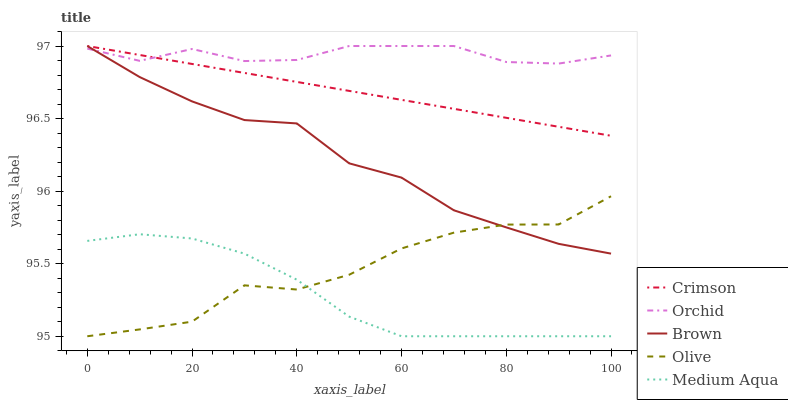Does Medium Aqua have the minimum area under the curve?
Answer yes or no. Yes. Does Orchid have the maximum area under the curve?
Answer yes or no. Yes. Does Brown have the minimum area under the curve?
Answer yes or no. No. Does Brown have the maximum area under the curve?
Answer yes or no. No. Is Crimson the smoothest?
Answer yes or no. Yes. Is Olive the roughest?
Answer yes or no. Yes. Is Brown the smoothest?
Answer yes or no. No. Is Brown the roughest?
Answer yes or no. No. Does Olive have the lowest value?
Answer yes or no. Yes. Does Brown have the lowest value?
Answer yes or no. No. Does Orchid have the highest value?
Answer yes or no. Yes. Does Olive have the highest value?
Answer yes or no. No. Is Medium Aqua less than Orchid?
Answer yes or no. Yes. Is Brown greater than Medium Aqua?
Answer yes or no. Yes. Does Brown intersect Crimson?
Answer yes or no. Yes. Is Brown less than Crimson?
Answer yes or no. No. Is Brown greater than Crimson?
Answer yes or no. No. Does Medium Aqua intersect Orchid?
Answer yes or no. No. 